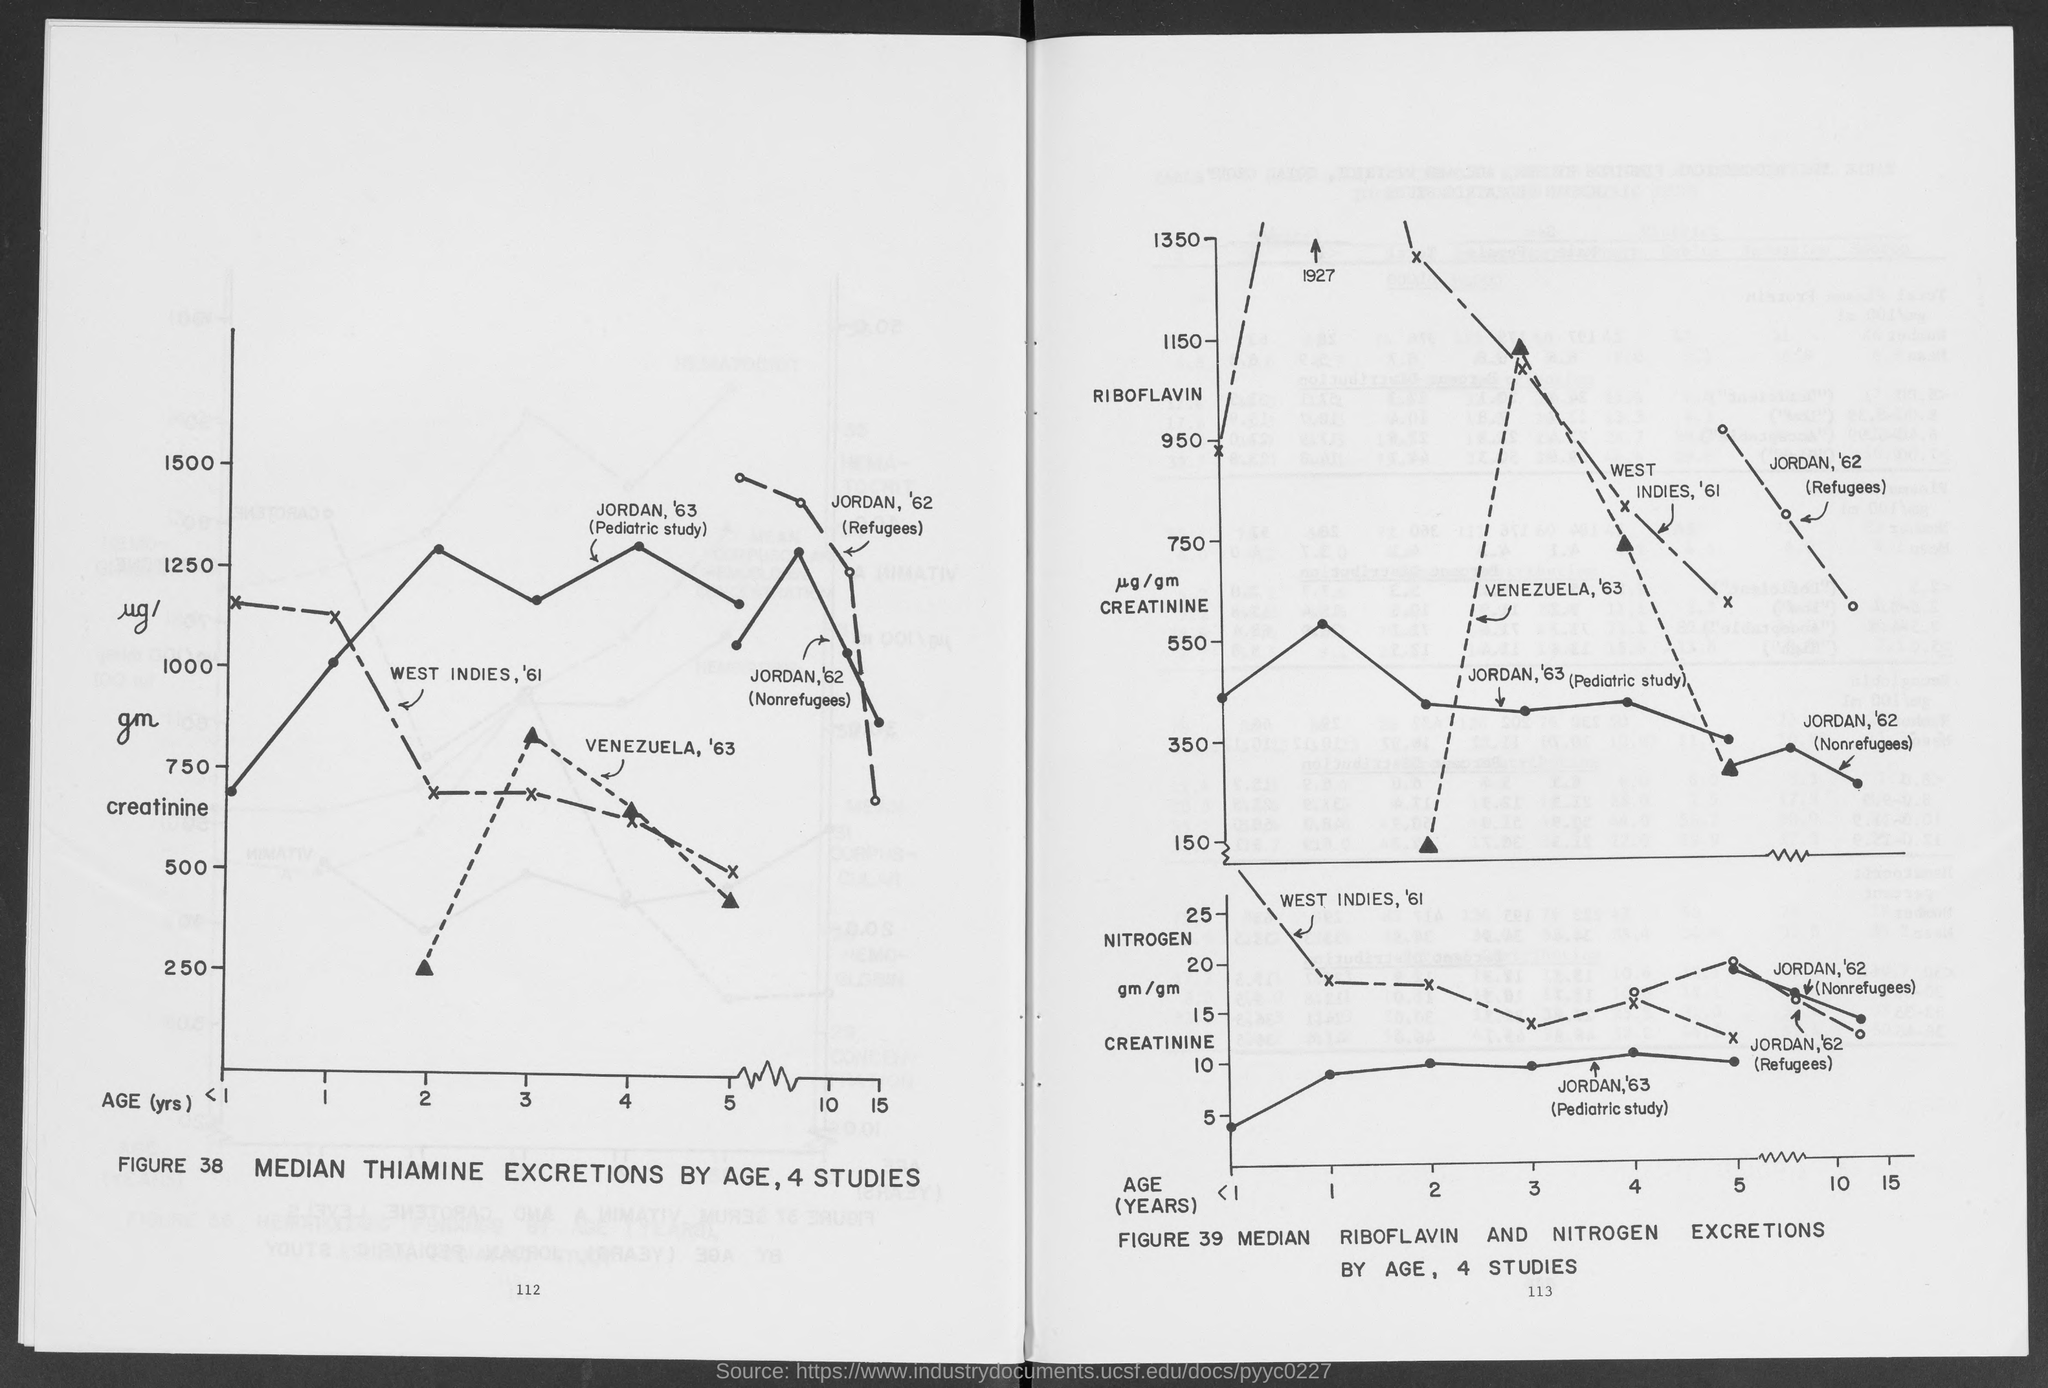Give some essential details in this illustration. The creatinine median for thiamine excretions for individuals aged 2 years in Venezuela, in the year 1963, was 250 micrograms. 